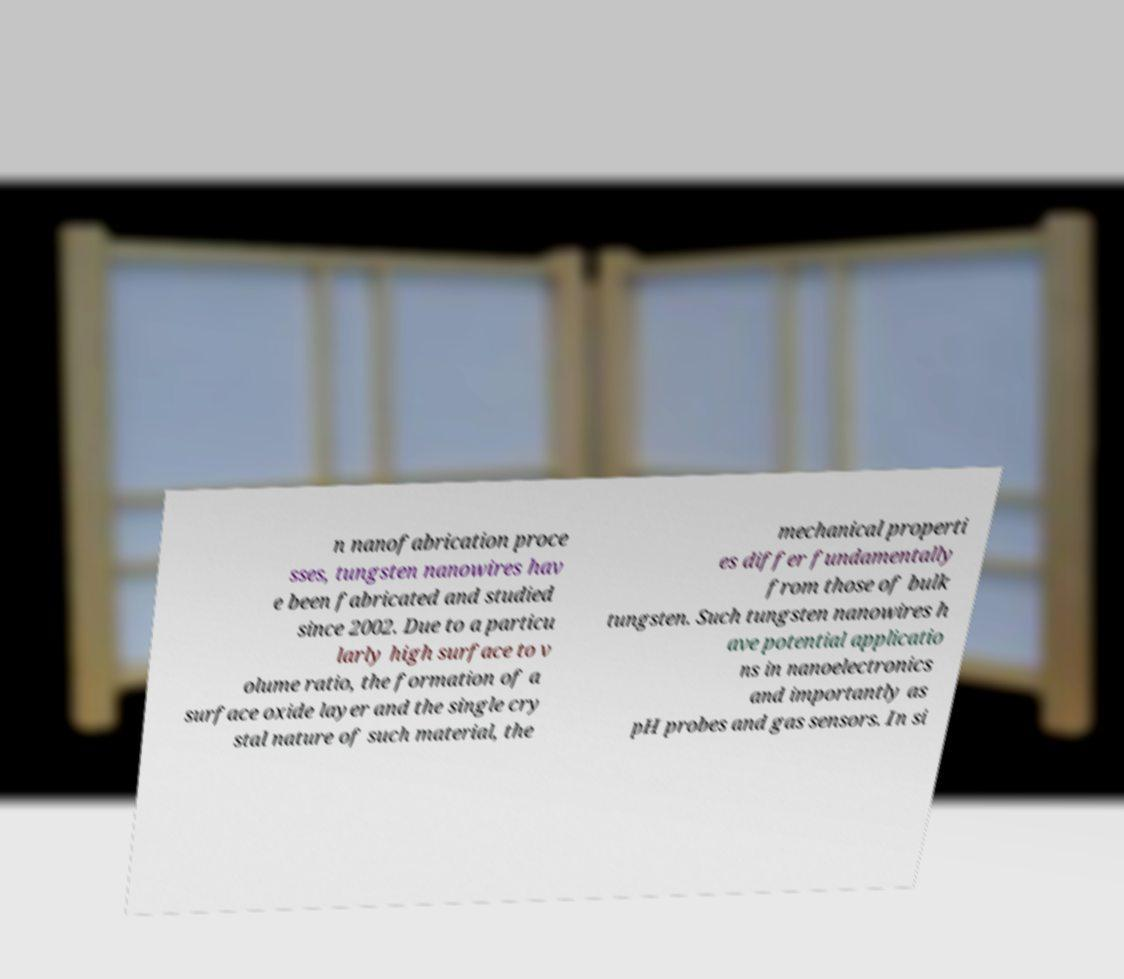Could you assist in decoding the text presented in this image and type it out clearly? n nanofabrication proce sses, tungsten nanowires hav e been fabricated and studied since 2002. Due to a particu larly high surface to v olume ratio, the formation of a surface oxide layer and the single cry stal nature of such material, the mechanical properti es differ fundamentally from those of bulk tungsten. Such tungsten nanowires h ave potential applicatio ns in nanoelectronics and importantly as pH probes and gas sensors. In si 